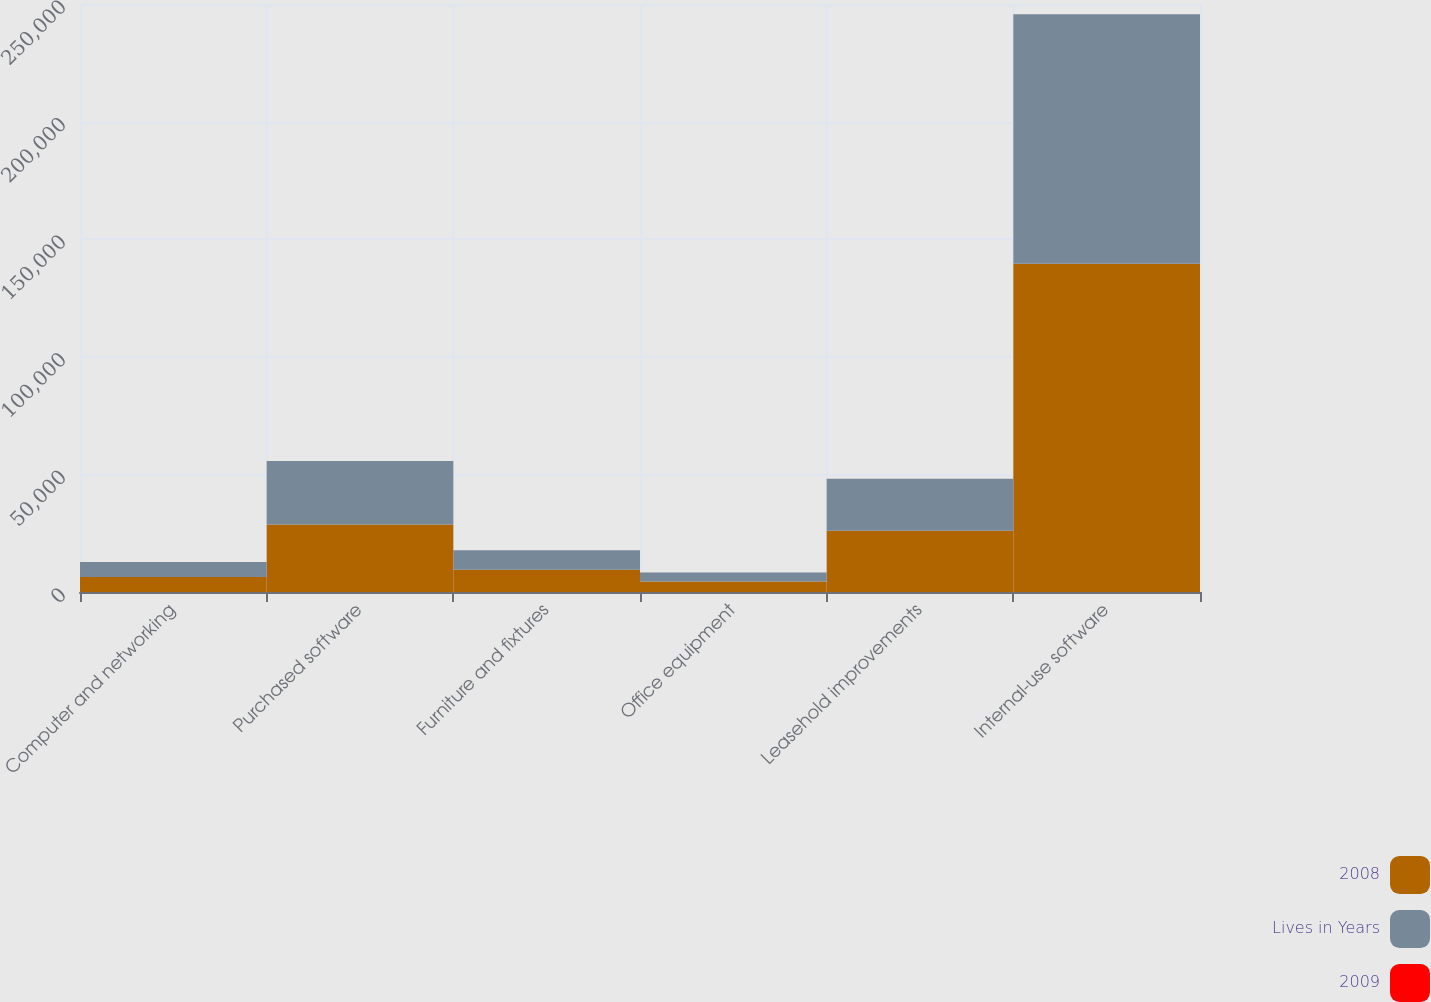Convert chart. <chart><loc_0><loc_0><loc_500><loc_500><stacked_bar_chart><ecel><fcel>Computer and networking<fcel>Purchased software<fcel>Furniture and fixtures<fcel>Office equipment<fcel>Leasehold improvements<fcel>Internal-use software<nl><fcel>2008<fcel>6382.5<fcel>28713<fcel>9491<fcel>4479<fcel>26026<fcel>139585<nl><fcel>Lives in Years<fcel>6382.5<fcel>26987<fcel>8286<fcel>3834<fcel>22095<fcel>106075<nl><fcel>2009<fcel>3<fcel>3<fcel>5<fcel>3<fcel>27<fcel>2<nl></chart> 